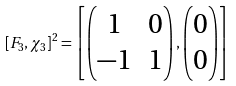Convert formula to latex. <formula><loc_0><loc_0><loc_500><loc_500>[ F _ { 3 } , \chi _ { 3 } ] ^ { 2 } = \left [ \begin{pmatrix} 1 & 0 \\ - 1 & 1 \end{pmatrix} , \begin{pmatrix} 0 \\ 0 \end{pmatrix} \right ]</formula> 